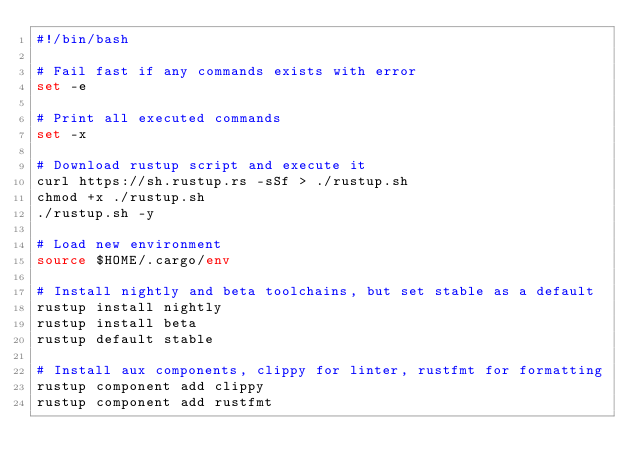<code> <loc_0><loc_0><loc_500><loc_500><_Bash_>#!/bin/bash

# Fail fast if any commands exists with error
set -e

# Print all executed commands
set -x

# Download rustup script and execute it
curl https://sh.rustup.rs -sSf > ./rustup.sh
chmod +x ./rustup.sh
./rustup.sh -y

# Load new environment
source $HOME/.cargo/env

# Install nightly and beta toolchains, but set stable as a default
rustup install nightly
rustup install beta
rustup default stable

# Install aux components, clippy for linter, rustfmt for formatting
rustup component add clippy
rustup component add rustfmt
</code> 